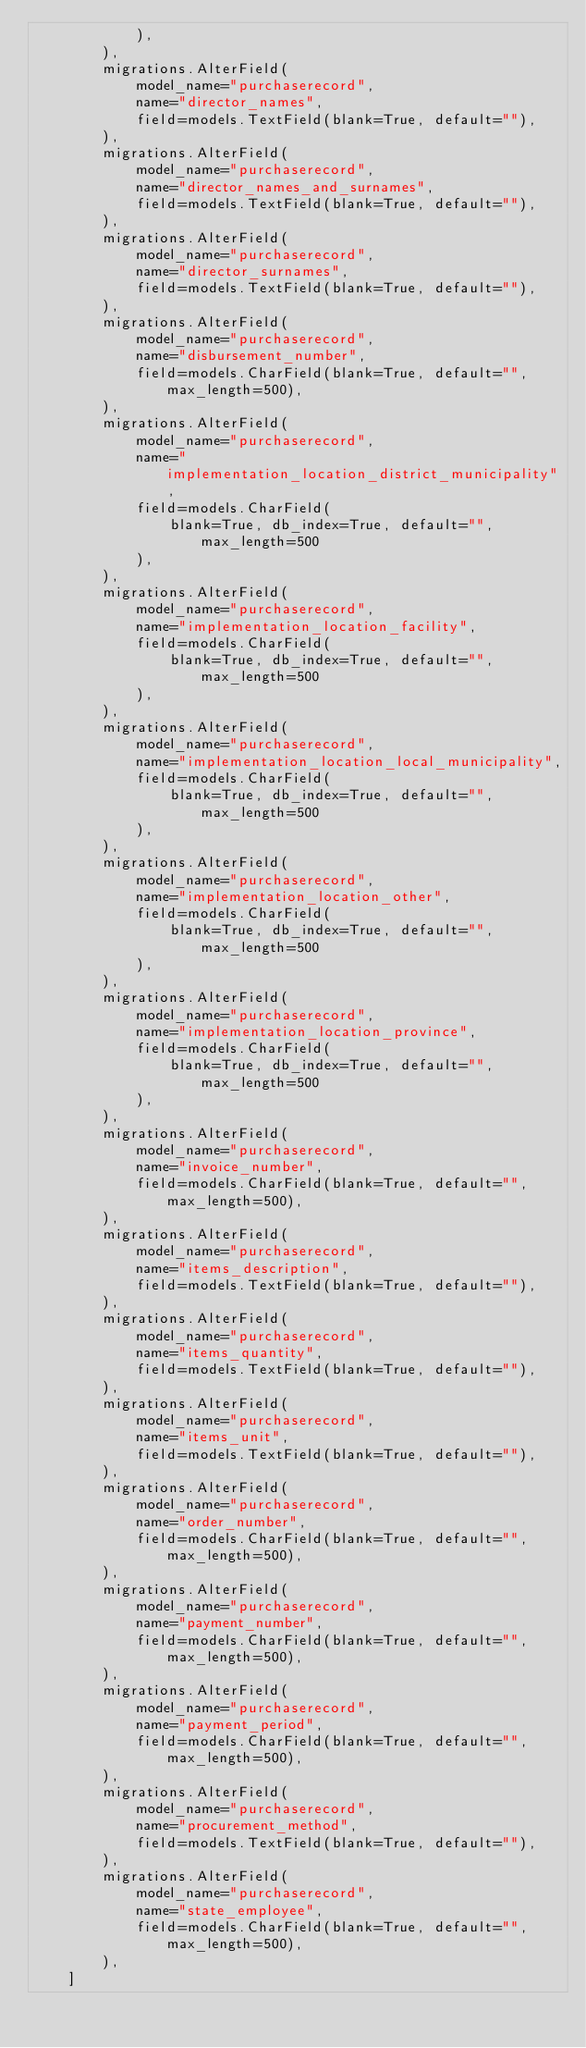<code> <loc_0><loc_0><loc_500><loc_500><_Python_>            ),
        ),
        migrations.AlterField(
            model_name="purchaserecord",
            name="director_names",
            field=models.TextField(blank=True, default=""),
        ),
        migrations.AlterField(
            model_name="purchaserecord",
            name="director_names_and_surnames",
            field=models.TextField(blank=True, default=""),
        ),
        migrations.AlterField(
            model_name="purchaserecord",
            name="director_surnames",
            field=models.TextField(blank=True, default=""),
        ),
        migrations.AlterField(
            model_name="purchaserecord",
            name="disbursement_number",
            field=models.CharField(blank=True, default="", max_length=500),
        ),
        migrations.AlterField(
            model_name="purchaserecord",
            name="implementation_location_district_municipality",
            field=models.CharField(
                blank=True, db_index=True, default="", max_length=500
            ),
        ),
        migrations.AlterField(
            model_name="purchaserecord",
            name="implementation_location_facility",
            field=models.CharField(
                blank=True, db_index=True, default="", max_length=500
            ),
        ),
        migrations.AlterField(
            model_name="purchaserecord",
            name="implementation_location_local_municipality",
            field=models.CharField(
                blank=True, db_index=True, default="", max_length=500
            ),
        ),
        migrations.AlterField(
            model_name="purchaserecord",
            name="implementation_location_other",
            field=models.CharField(
                blank=True, db_index=True, default="", max_length=500
            ),
        ),
        migrations.AlterField(
            model_name="purchaserecord",
            name="implementation_location_province",
            field=models.CharField(
                blank=True, db_index=True, default="", max_length=500
            ),
        ),
        migrations.AlterField(
            model_name="purchaserecord",
            name="invoice_number",
            field=models.CharField(blank=True, default="", max_length=500),
        ),
        migrations.AlterField(
            model_name="purchaserecord",
            name="items_description",
            field=models.TextField(blank=True, default=""),
        ),
        migrations.AlterField(
            model_name="purchaserecord",
            name="items_quantity",
            field=models.TextField(blank=True, default=""),
        ),
        migrations.AlterField(
            model_name="purchaserecord",
            name="items_unit",
            field=models.TextField(blank=True, default=""),
        ),
        migrations.AlterField(
            model_name="purchaserecord",
            name="order_number",
            field=models.CharField(blank=True, default="", max_length=500),
        ),
        migrations.AlterField(
            model_name="purchaserecord",
            name="payment_number",
            field=models.CharField(blank=True, default="", max_length=500),
        ),
        migrations.AlterField(
            model_name="purchaserecord",
            name="payment_period",
            field=models.CharField(blank=True, default="", max_length=500),
        ),
        migrations.AlterField(
            model_name="purchaserecord",
            name="procurement_method",
            field=models.TextField(blank=True, default=""),
        ),
        migrations.AlterField(
            model_name="purchaserecord",
            name="state_employee",
            field=models.CharField(blank=True, default="", max_length=500),
        ),
    ]
</code> 